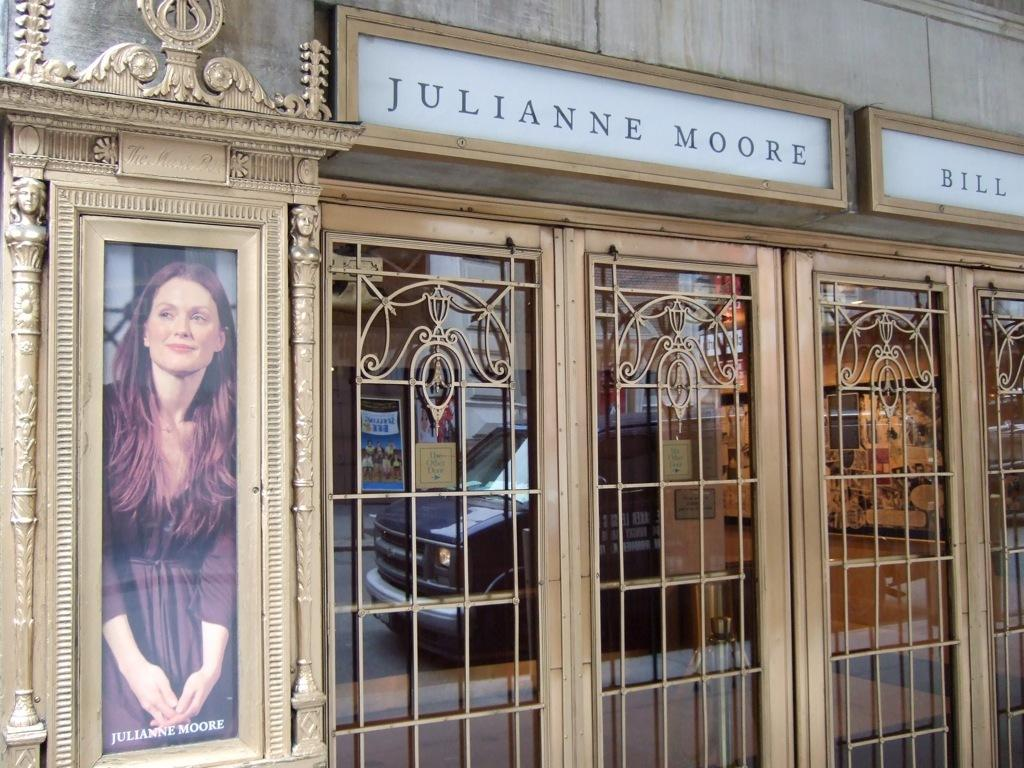<image>
Share a concise interpretation of the image provided. Julianne moore sign above a building including her picture on the left side 